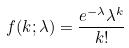<formula> <loc_0><loc_0><loc_500><loc_500>f ( k ; \lambda ) = \frac { e ^ { - \lambda } \lambda ^ { k } } { k ! }</formula> 